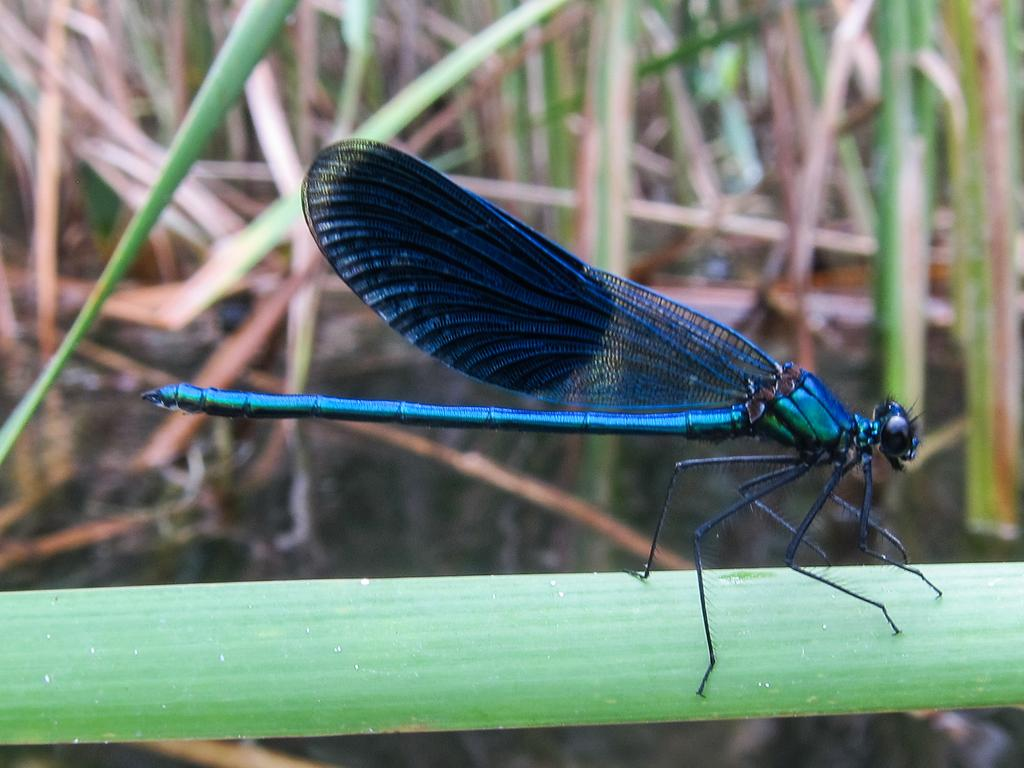What insect is present in the image? There is a dragonfly in the image. Where is the dragonfly located? The dragonfly is on a leaf. What color are the leaves in the image? The leaves in the image are green. What substance is the dragonfly using to paint the leaves in the image? There is no substance or painting activity present in the image; the dragonfly is simply resting on a leaf. 